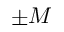<formula> <loc_0><loc_0><loc_500><loc_500>\pm M</formula> 